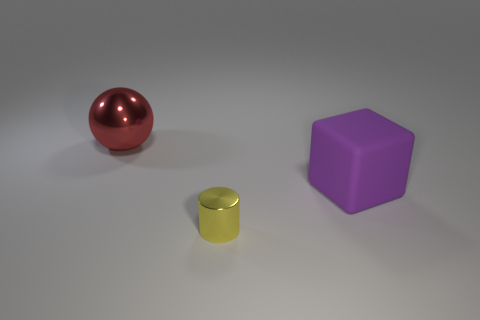What can we infer about the light source in this image? Based on the shadows and highlights, there appears to be a single light source illuminating the scene from above, slightly towards the front. The light's diffusion suggests it's not overly harsh, as the shadows have soft edges and are not overly dark. 